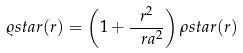Convert formula to latex. <formula><loc_0><loc_0><loc_500><loc_500>\varrho s t a r ( r ) = \left ( 1 + \frac { r ^ { 2 } } { \ r a ^ { 2 } } \right ) \rho s t a r ( r )</formula> 